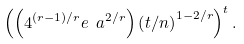Convert formula to latex. <formula><loc_0><loc_0><loc_500><loc_500>\left ( \left ( 4 ^ { ( r - 1 ) / r } e \ a ^ { 2 / r } \right ) \left ( t / n \right ) ^ { 1 - 2 / r } \right ) ^ { t } .</formula> 